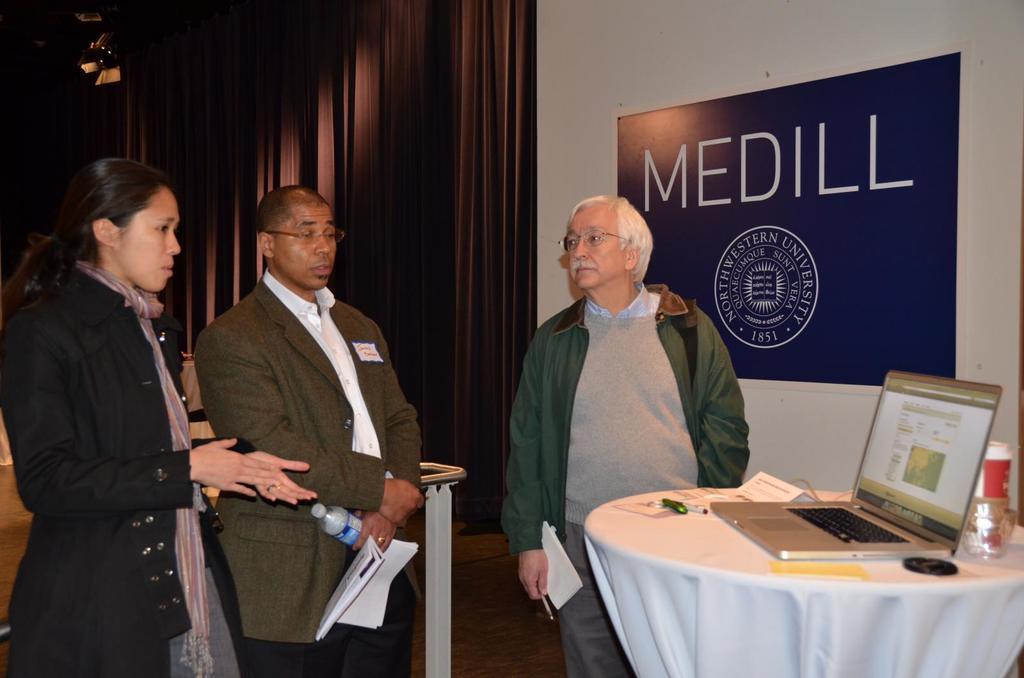In one or two sentences, can you explain what this image depicts? On the background we can see curtains, light, a board over a wall. here we can see three persons standing in front of a table and on the table we can see laptop, glass, bottle, marker and a paper. These both men is holding papers and This man holding a bottle in his hand. They both wear spectacle. 